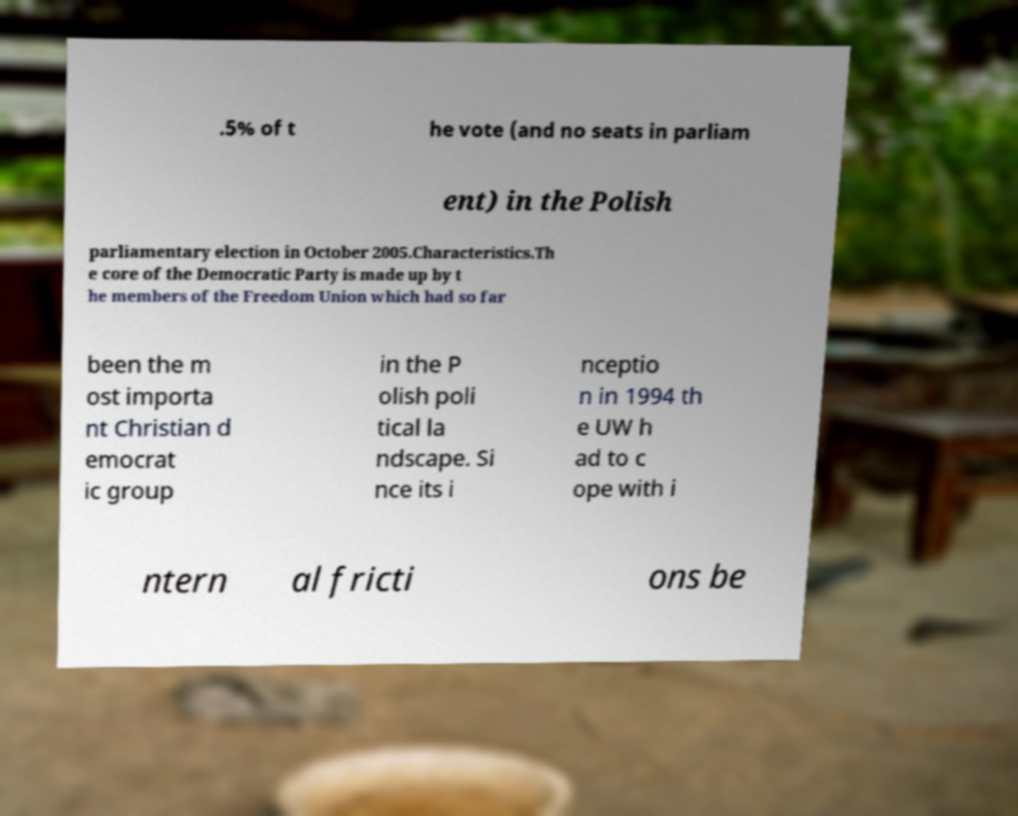Please read and relay the text visible in this image. What does it say? .5% of t he vote (and no seats in parliam ent) in the Polish parliamentary election in October 2005.Characteristics.Th e core of the Democratic Party is made up by t he members of the Freedom Union which had so far been the m ost importa nt Christian d emocrat ic group in the P olish poli tical la ndscape. Si nce its i nceptio n in 1994 th e UW h ad to c ope with i ntern al fricti ons be 